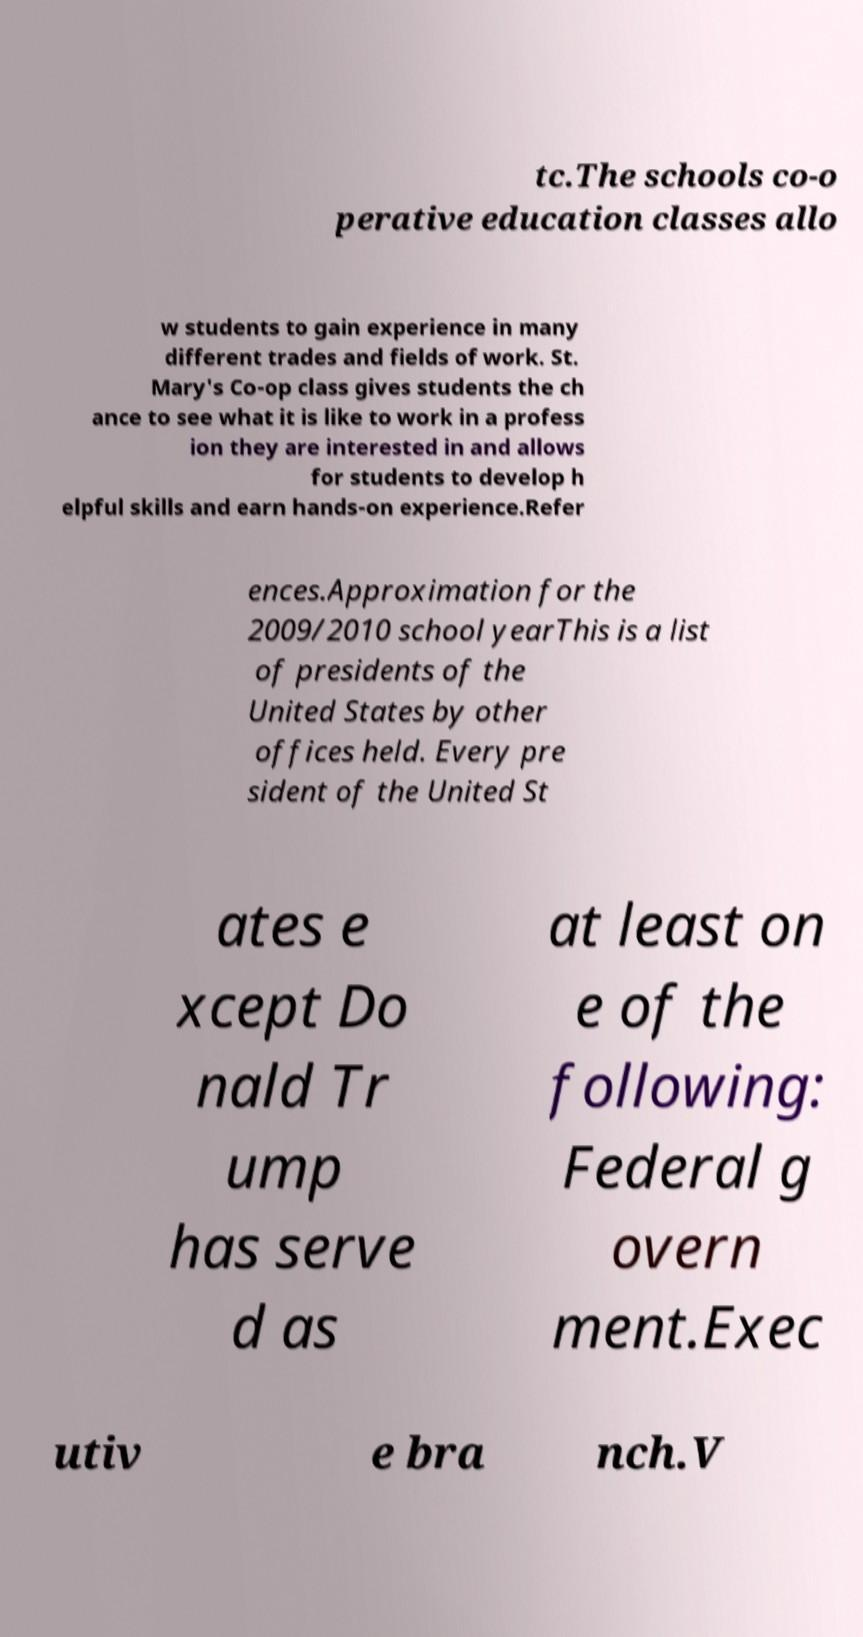Could you extract and type out the text from this image? tc.The schools co-o perative education classes allo w students to gain experience in many different trades and fields of work. St. Mary's Co-op class gives students the ch ance to see what it is like to work in a profess ion they are interested in and allows for students to develop h elpful skills and earn hands-on experience.Refer ences.Approximation for the 2009/2010 school yearThis is a list of presidents of the United States by other offices held. Every pre sident of the United St ates e xcept Do nald Tr ump has serve d as at least on e of the following: Federal g overn ment.Exec utiv e bra nch.V 